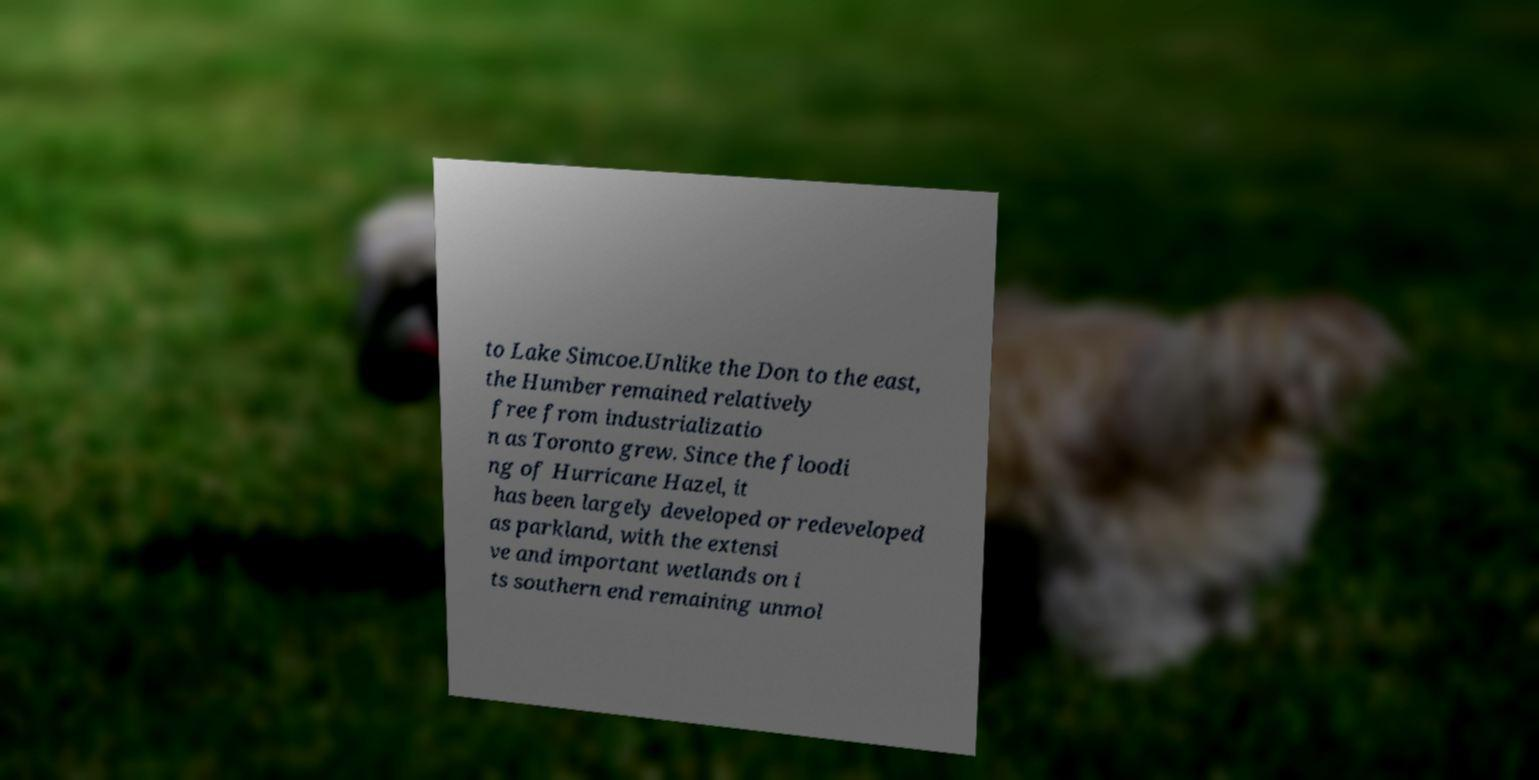Please read and relay the text visible in this image. What does it say? to Lake Simcoe.Unlike the Don to the east, the Humber remained relatively free from industrializatio n as Toronto grew. Since the floodi ng of Hurricane Hazel, it has been largely developed or redeveloped as parkland, with the extensi ve and important wetlands on i ts southern end remaining unmol 